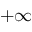<formula> <loc_0><loc_0><loc_500><loc_500>+ \infty</formula> 